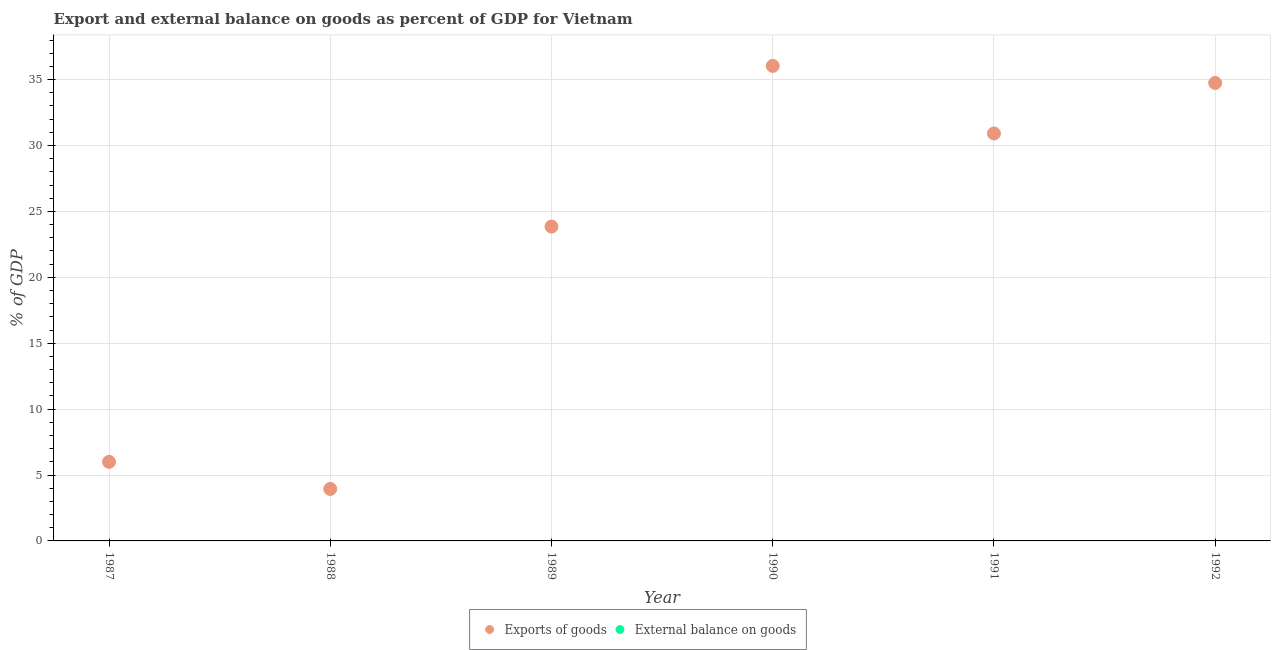Is the number of dotlines equal to the number of legend labels?
Give a very brief answer. No. What is the export of goods as percentage of gdp in 1988?
Keep it short and to the point. 3.95. Across all years, what is the maximum export of goods as percentage of gdp?
Offer a terse response. 36.04. What is the difference between the export of goods as percentage of gdp in 1989 and that in 1992?
Provide a short and direct response. -10.9. What is the difference between the export of goods as percentage of gdp in 1990 and the external balance on goods as percentage of gdp in 1991?
Make the answer very short. 36.04. What is the average external balance on goods as percentage of gdp per year?
Your response must be concise. 0. In how many years, is the export of goods as percentage of gdp greater than 5 %?
Provide a succinct answer. 5. What is the ratio of the export of goods as percentage of gdp in 1991 to that in 1992?
Your answer should be compact. 0.89. Is the export of goods as percentage of gdp in 1987 less than that in 1988?
Your answer should be very brief. No. What is the difference between the highest and the second highest export of goods as percentage of gdp?
Keep it short and to the point. 1.29. What is the difference between the highest and the lowest export of goods as percentage of gdp?
Make the answer very short. 32.09. In how many years, is the external balance on goods as percentage of gdp greater than the average external balance on goods as percentage of gdp taken over all years?
Your response must be concise. 0. Is the sum of the export of goods as percentage of gdp in 1990 and 1991 greater than the maximum external balance on goods as percentage of gdp across all years?
Ensure brevity in your answer.  Yes. Is the external balance on goods as percentage of gdp strictly greater than the export of goods as percentage of gdp over the years?
Your answer should be compact. No. How many years are there in the graph?
Provide a short and direct response. 6. What is the difference between two consecutive major ticks on the Y-axis?
Your response must be concise. 5. Are the values on the major ticks of Y-axis written in scientific E-notation?
Offer a very short reply. No. Does the graph contain grids?
Ensure brevity in your answer.  Yes. How many legend labels are there?
Keep it short and to the point. 2. How are the legend labels stacked?
Keep it short and to the point. Horizontal. What is the title of the graph?
Offer a terse response. Export and external balance on goods as percent of GDP for Vietnam. What is the label or title of the X-axis?
Keep it short and to the point. Year. What is the label or title of the Y-axis?
Make the answer very short. % of GDP. What is the % of GDP of Exports of goods in 1987?
Offer a terse response. 6. What is the % of GDP in External balance on goods in 1987?
Offer a very short reply. 0. What is the % of GDP in Exports of goods in 1988?
Your answer should be compact. 3.95. What is the % of GDP of External balance on goods in 1988?
Give a very brief answer. 0. What is the % of GDP of Exports of goods in 1989?
Make the answer very short. 23.85. What is the % of GDP of Exports of goods in 1990?
Keep it short and to the point. 36.04. What is the % of GDP of External balance on goods in 1990?
Your answer should be compact. 0. What is the % of GDP of Exports of goods in 1991?
Keep it short and to the point. 30.92. What is the % of GDP of External balance on goods in 1991?
Your answer should be compact. 0. What is the % of GDP in Exports of goods in 1992?
Provide a short and direct response. 34.75. What is the % of GDP in External balance on goods in 1992?
Your answer should be very brief. 0. Across all years, what is the maximum % of GDP of Exports of goods?
Offer a terse response. 36.04. Across all years, what is the minimum % of GDP of Exports of goods?
Your answer should be very brief. 3.95. What is the total % of GDP in Exports of goods in the graph?
Your response must be concise. 135.5. What is the total % of GDP of External balance on goods in the graph?
Your response must be concise. 0. What is the difference between the % of GDP of Exports of goods in 1987 and that in 1988?
Provide a short and direct response. 2.06. What is the difference between the % of GDP of Exports of goods in 1987 and that in 1989?
Keep it short and to the point. -17.85. What is the difference between the % of GDP in Exports of goods in 1987 and that in 1990?
Give a very brief answer. -30.04. What is the difference between the % of GDP of Exports of goods in 1987 and that in 1991?
Your answer should be very brief. -24.91. What is the difference between the % of GDP in Exports of goods in 1987 and that in 1992?
Offer a terse response. -28.74. What is the difference between the % of GDP of Exports of goods in 1988 and that in 1989?
Offer a terse response. -19.9. What is the difference between the % of GDP of Exports of goods in 1988 and that in 1990?
Provide a succinct answer. -32.09. What is the difference between the % of GDP of Exports of goods in 1988 and that in 1991?
Your response must be concise. -26.97. What is the difference between the % of GDP in Exports of goods in 1988 and that in 1992?
Ensure brevity in your answer.  -30.8. What is the difference between the % of GDP of Exports of goods in 1989 and that in 1990?
Provide a short and direct response. -12.19. What is the difference between the % of GDP in Exports of goods in 1989 and that in 1991?
Provide a succinct answer. -7.07. What is the difference between the % of GDP of Exports of goods in 1989 and that in 1992?
Provide a succinct answer. -10.9. What is the difference between the % of GDP in Exports of goods in 1990 and that in 1991?
Your answer should be compact. 5.12. What is the difference between the % of GDP in Exports of goods in 1990 and that in 1992?
Your response must be concise. 1.29. What is the difference between the % of GDP of Exports of goods in 1991 and that in 1992?
Ensure brevity in your answer.  -3.83. What is the average % of GDP of Exports of goods per year?
Offer a very short reply. 22.58. What is the average % of GDP in External balance on goods per year?
Your answer should be very brief. 0. What is the ratio of the % of GDP of Exports of goods in 1987 to that in 1988?
Your response must be concise. 1.52. What is the ratio of the % of GDP in Exports of goods in 1987 to that in 1989?
Keep it short and to the point. 0.25. What is the ratio of the % of GDP in Exports of goods in 1987 to that in 1990?
Your answer should be compact. 0.17. What is the ratio of the % of GDP in Exports of goods in 1987 to that in 1991?
Offer a terse response. 0.19. What is the ratio of the % of GDP of Exports of goods in 1987 to that in 1992?
Provide a succinct answer. 0.17. What is the ratio of the % of GDP in Exports of goods in 1988 to that in 1989?
Your answer should be compact. 0.17. What is the ratio of the % of GDP in Exports of goods in 1988 to that in 1990?
Your answer should be very brief. 0.11. What is the ratio of the % of GDP in Exports of goods in 1988 to that in 1991?
Your answer should be very brief. 0.13. What is the ratio of the % of GDP in Exports of goods in 1988 to that in 1992?
Your response must be concise. 0.11. What is the ratio of the % of GDP of Exports of goods in 1989 to that in 1990?
Make the answer very short. 0.66. What is the ratio of the % of GDP of Exports of goods in 1989 to that in 1991?
Offer a very short reply. 0.77. What is the ratio of the % of GDP of Exports of goods in 1989 to that in 1992?
Keep it short and to the point. 0.69. What is the ratio of the % of GDP in Exports of goods in 1990 to that in 1991?
Ensure brevity in your answer.  1.17. What is the ratio of the % of GDP of Exports of goods in 1990 to that in 1992?
Make the answer very short. 1.04. What is the ratio of the % of GDP of Exports of goods in 1991 to that in 1992?
Your answer should be compact. 0.89. What is the difference between the highest and the second highest % of GDP in Exports of goods?
Offer a very short reply. 1.29. What is the difference between the highest and the lowest % of GDP in Exports of goods?
Provide a succinct answer. 32.09. 